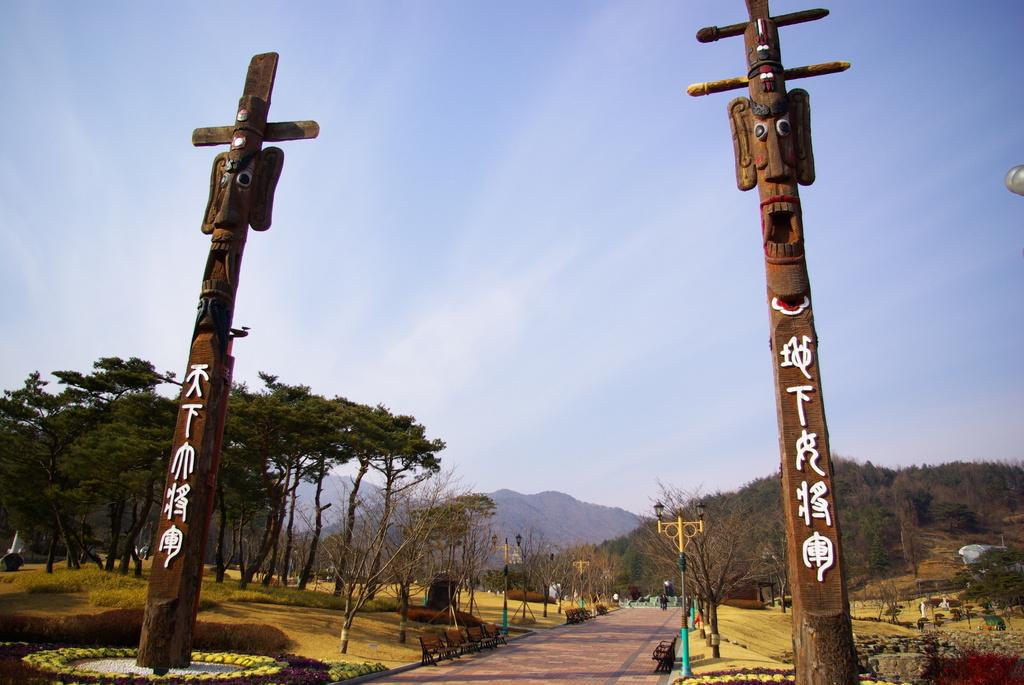What structures can be seen in the image? There are poles in the image. What type of vegetation is visible in the image? There is grass and trees visible in the image. What type of terrain is present in the image? There is a hill in the image. What type of lighting is present in the image? There are lights in the image. What can be seen in the sky in the image? Clouds are visible in the sky in the image. What advertisement can be seen on the hill in the image? There is no advertisement present on the hill in the image. How many planes are flying over the hill in the image? There are no planes visible in the image. 